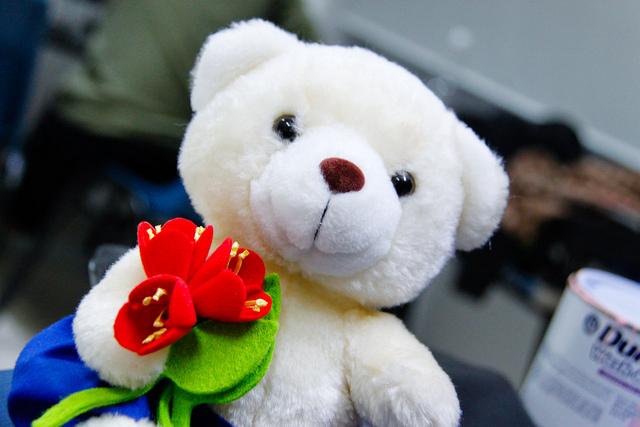What is the teddy holding?
Keep it brief. Flower. What is the teddy bear made of?
Be succinct. Cotton. What color are the bears?
Short answer required. White. What is to the right of the bear?
Write a very short answer. Paint can. 